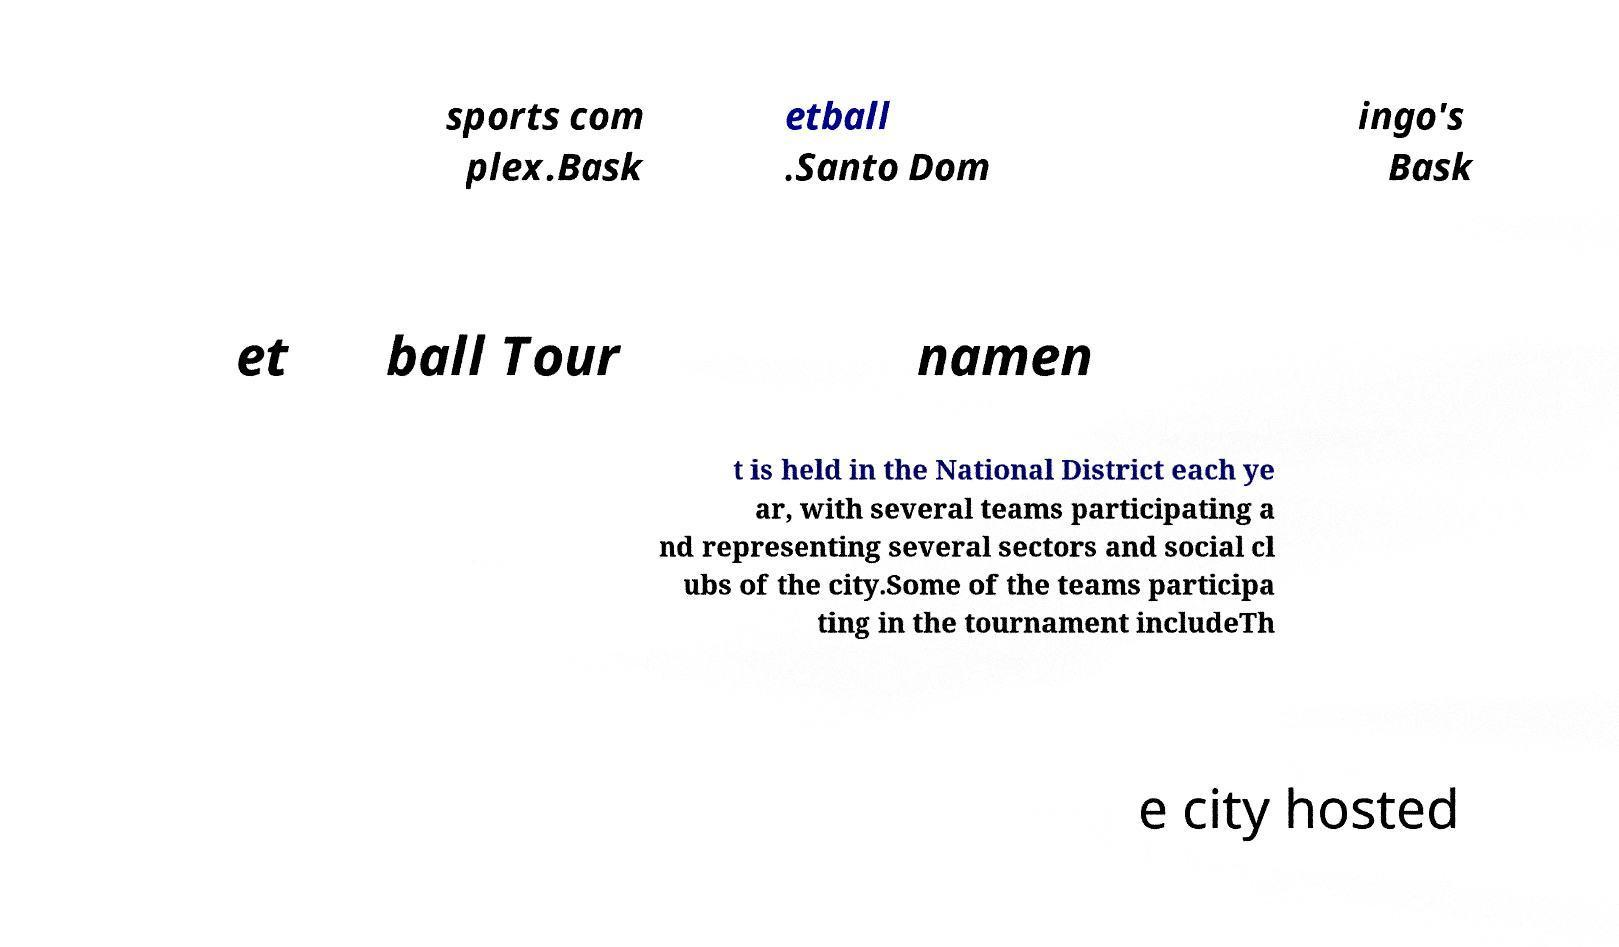Can you read and provide the text displayed in the image?This photo seems to have some interesting text. Can you extract and type it out for me? sports com plex.Bask etball .Santo Dom ingo's Bask et ball Tour namen t is held in the National District each ye ar, with several teams participating a nd representing several sectors and social cl ubs of the city.Some of the teams participa ting in the tournament includeTh e city hosted 